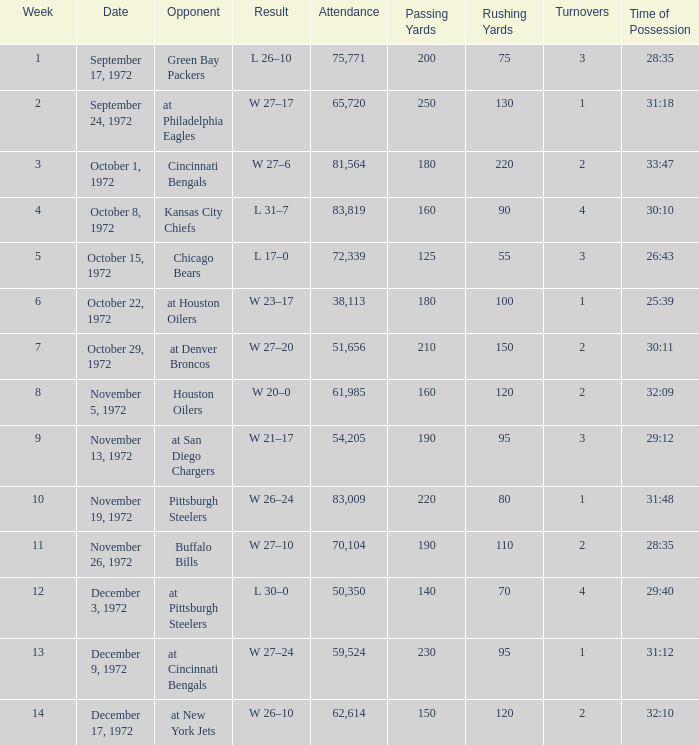What is the sum of week number(s) had an attendance of 61,985? 1.0. 